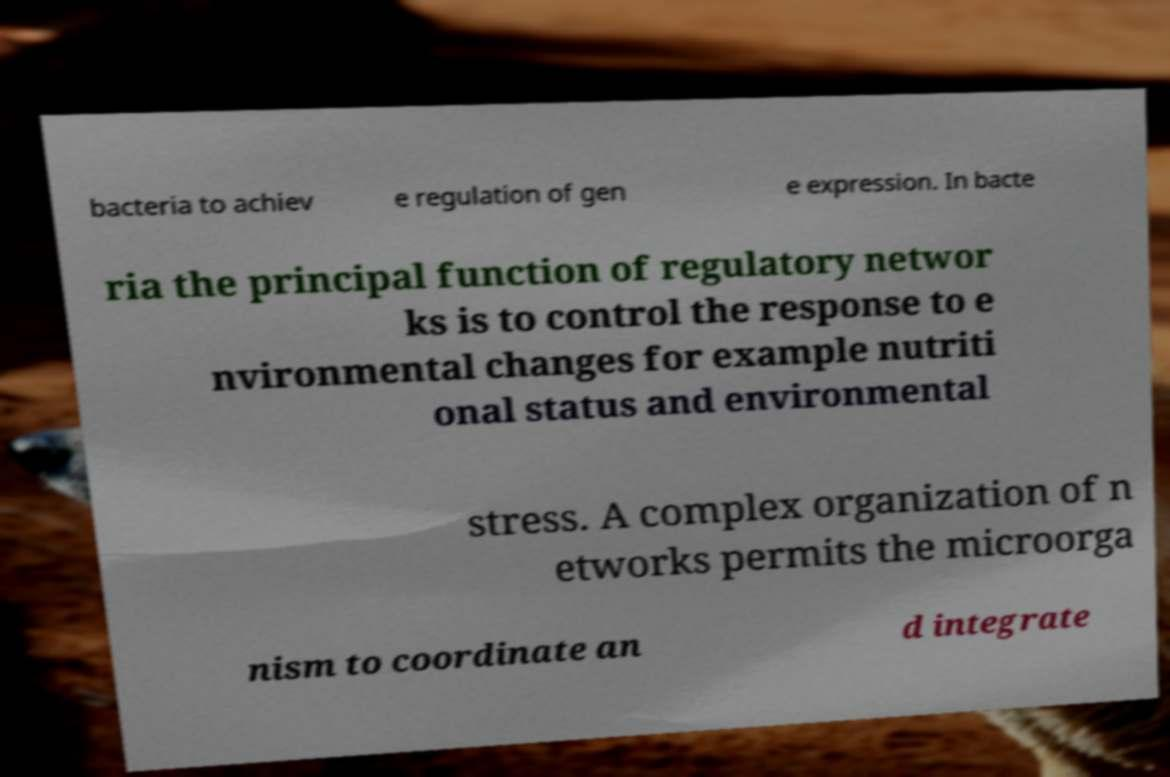I need the written content from this picture converted into text. Can you do that? bacteria to achiev e regulation of gen e expression. In bacte ria the principal function of regulatory networ ks is to control the response to e nvironmental changes for example nutriti onal status and environmental stress. A complex organization of n etworks permits the microorga nism to coordinate an d integrate 